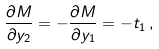Convert formula to latex. <formula><loc_0><loc_0><loc_500><loc_500>\frac { \partial M } { \partial y _ { 2 } } = - \frac { \partial M } { \partial y _ { 1 } } = - t _ { 1 } \, ,</formula> 